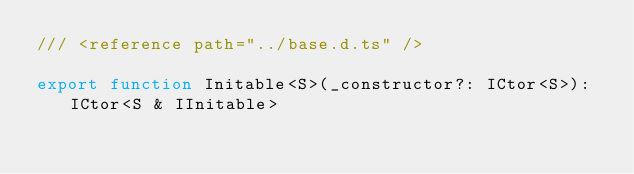<code> <loc_0><loc_0><loc_500><loc_500><_TypeScript_>/// <reference path="../base.d.ts" />

export function Initable<S>(_constructor?: ICtor<S>): ICtor<S & IInitable>
</code> 